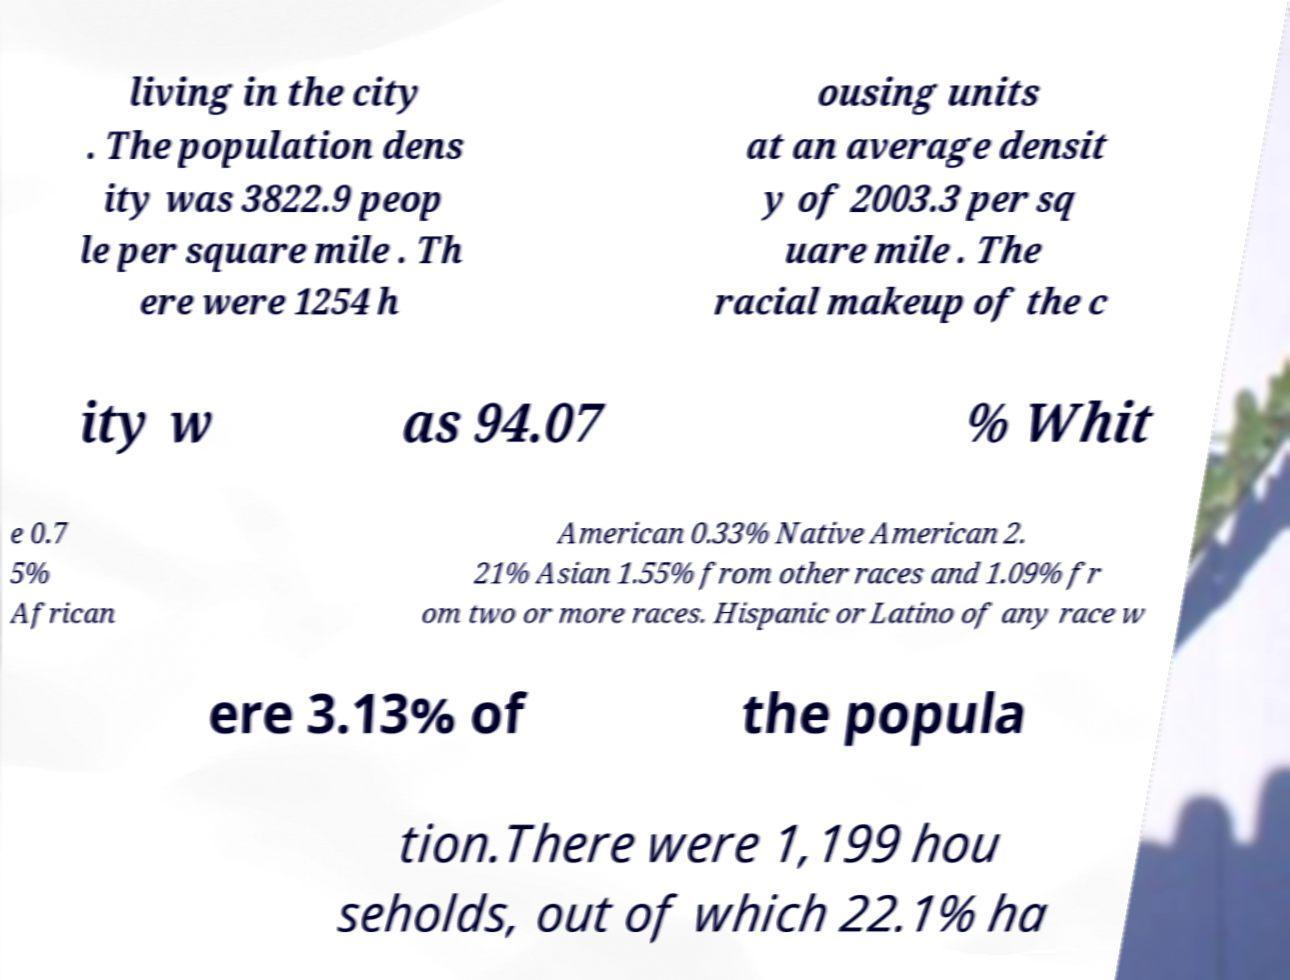Can you read and provide the text displayed in the image?This photo seems to have some interesting text. Can you extract and type it out for me? living in the city . The population dens ity was 3822.9 peop le per square mile . Th ere were 1254 h ousing units at an average densit y of 2003.3 per sq uare mile . The racial makeup of the c ity w as 94.07 % Whit e 0.7 5% African American 0.33% Native American 2. 21% Asian 1.55% from other races and 1.09% fr om two or more races. Hispanic or Latino of any race w ere 3.13% of the popula tion.There were 1,199 hou seholds, out of which 22.1% ha 